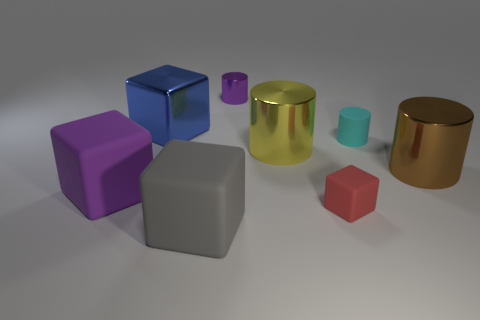Subtract all matte cubes. How many cubes are left? 1 Add 2 small cyan objects. How many objects exist? 10 Subtract all red cylinders. Subtract all cyan balls. How many cylinders are left? 4 Subtract 0 brown balls. How many objects are left? 8 Subtract all shiny spheres. Subtract all shiny things. How many objects are left? 4 Add 5 big brown metal things. How many big brown metal things are left? 6 Add 5 large gray shiny cylinders. How many large gray shiny cylinders exist? 5 